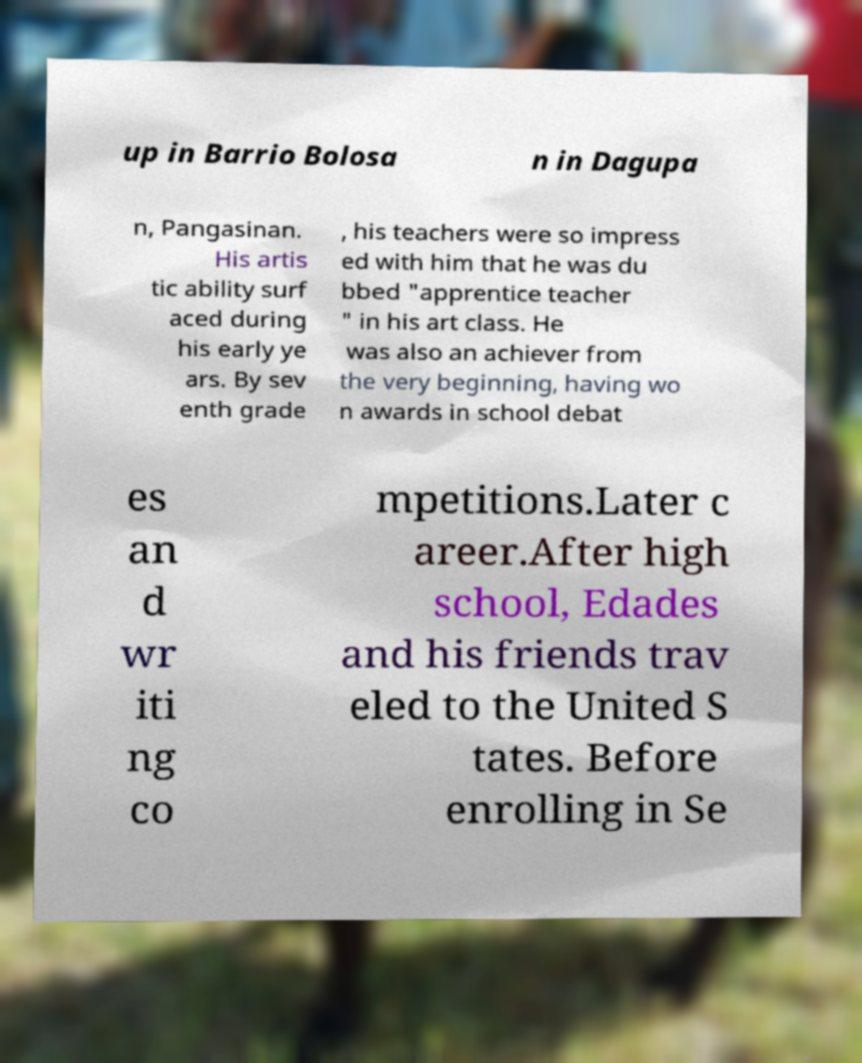For documentation purposes, I need the text within this image transcribed. Could you provide that? up in Barrio Bolosa n in Dagupa n, Pangasinan. His artis tic ability surf aced during his early ye ars. By sev enth grade , his teachers were so impress ed with him that he was du bbed "apprentice teacher " in his art class. He was also an achiever from the very beginning, having wo n awards in school debat es an d wr iti ng co mpetitions.Later c areer.After high school, Edades and his friends trav eled to the United S tates. Before enrolling in Se 